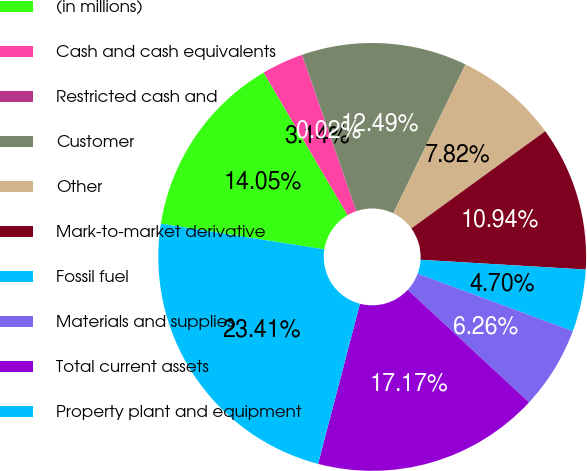Convert chart. <chart><loc_0><loc_0><loc_500><loc_500><pie_chart><fcel>(in millions)<fcel>Cash and cash equivalents<fcel>Restricted cash and<fcel>Customer<fcel>Other<fcel>Mark-to-market derivative<fcel>Fossil fuel<fcel>Materials and supplies<fcel>Total current assets<fcel>Property plant and equipment<nl><fcel>14.05%<fcel>3.14%<fcel>0.02%<fcel>12.49%<fcel>7.82%<fcel>10.94%<fcel>4.7%<fcel>6.26%<fcel>17.17%<fcel>23.41%<nl></chart> 